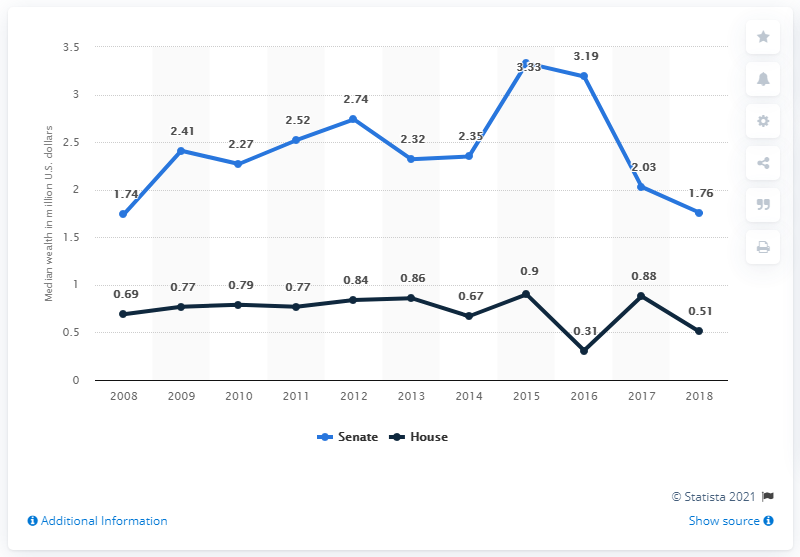Draw attention to some important aspects in this diagram. In 2018, the median wealth of members of the Senate was 1.76. 